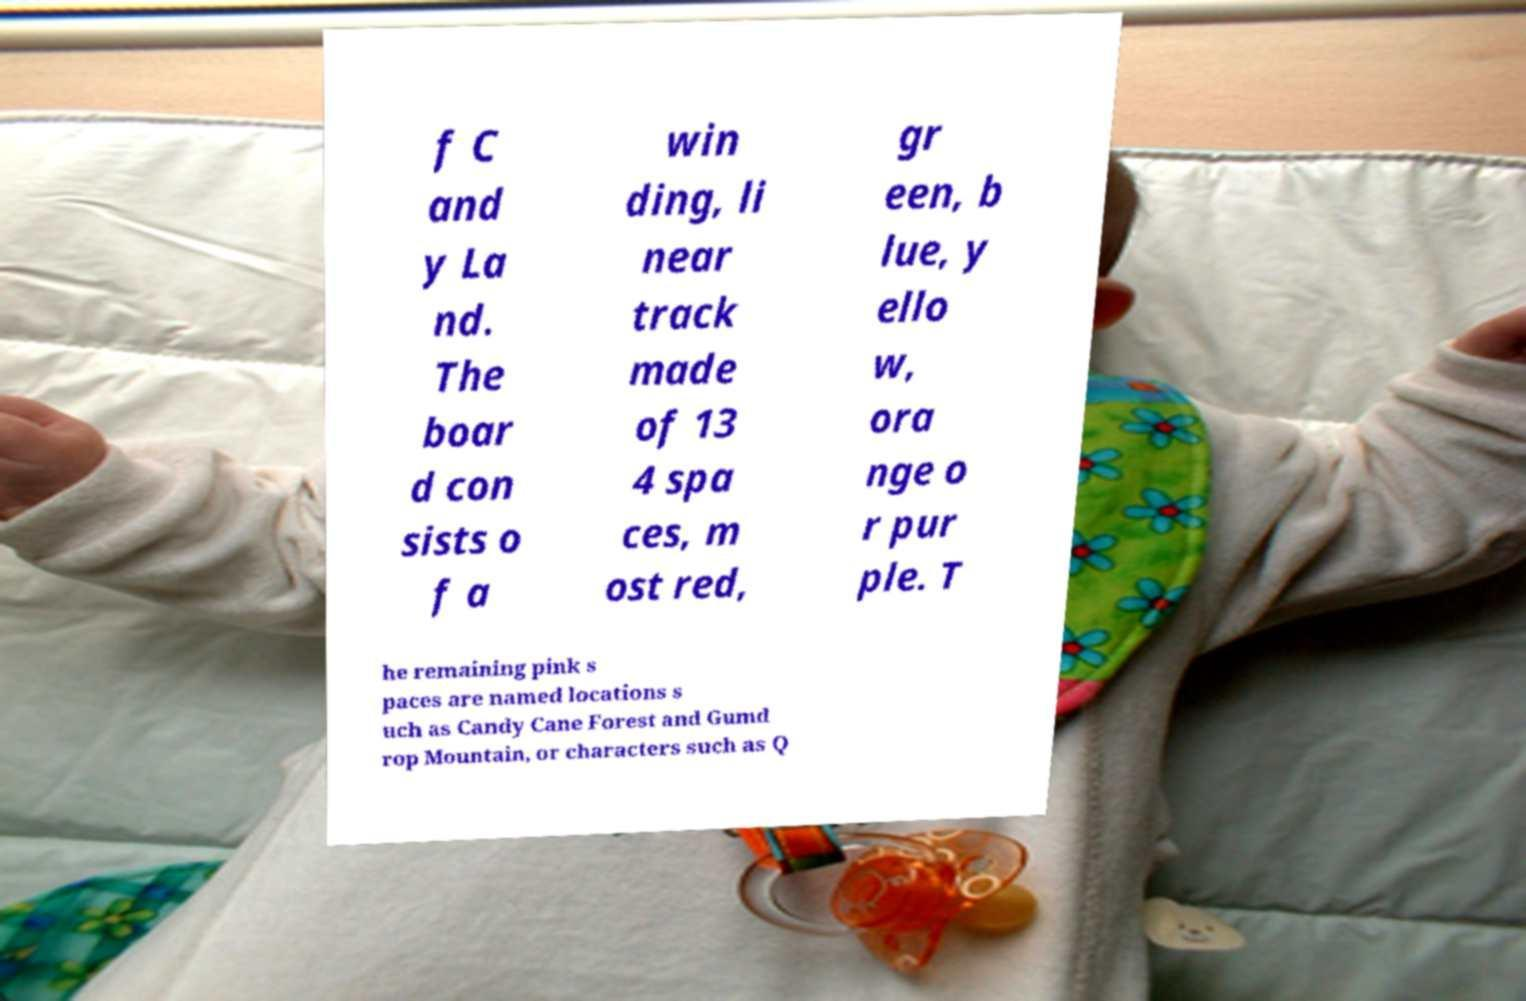Could you assist in decoding the text presented in this image and type it out clearly? f C and y La nd. The boar d con sists o f a win ding, li near track made of 13 4 spa ces, m ost red, gr een, b lue, y ello w, ora nge o r pur ple. T he remaining pink s paces are named locations s uch as Candy Cane Forest and Gumd rop Mountain, or characters such as Q 